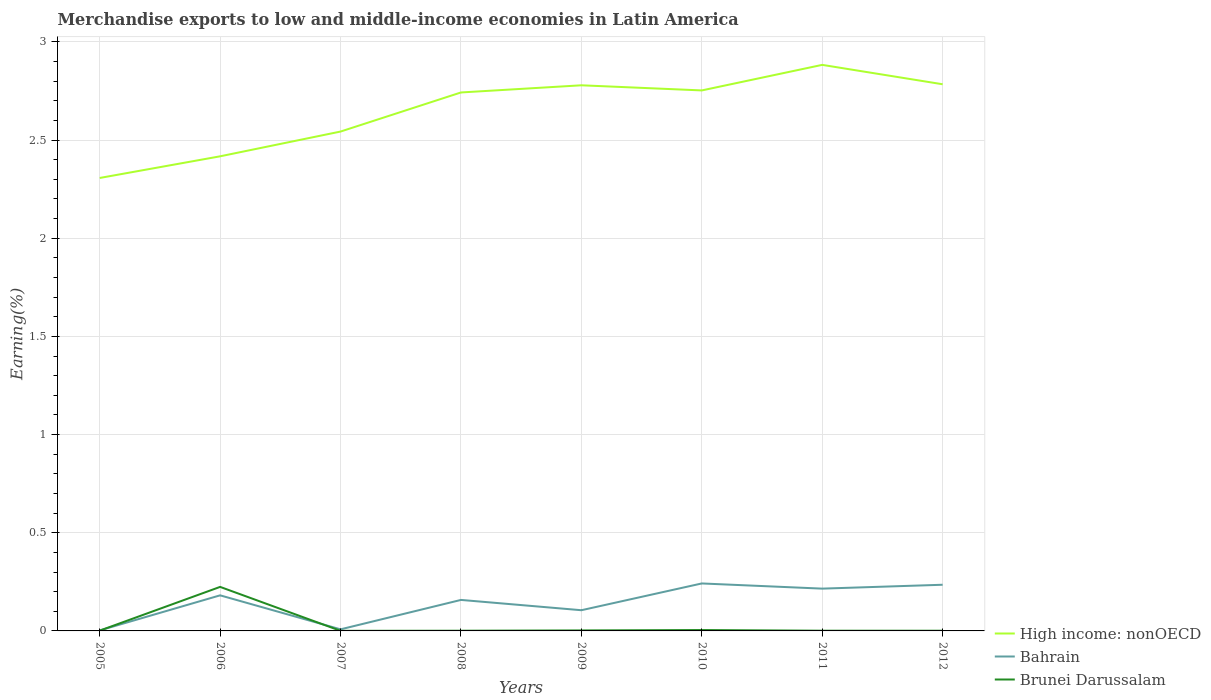Does the line corresponding to High income: nonOECD intersect with the line corresponding to Brunei Darussalam?
Your answer should be compact. No. Is the number of lines equal to the number of legend labels?
Your answer should be compact. Yes. Across all years, what is the maximum percentage of amount earned from merchandise exports in Brunei Darussalam?
Ensure brevity in your answer.  0. What is the total percentage of amount earned from merchandise exports in Brunei Darussalam in the graph?
Your answer should be very brief. 0. What is the difference between the highest and the second highest percentage of amount earned from merchandise exports in Bahrain?
Offer a very short reply. 0.24. What is the difference between the highest and the lowest percentage of amount earned from merchandise exports in Brunei Darussalam?
Your answer should be very brief. 1. How many lines are there?
Offer a terse response. 3. How many years are there in the graph?
Offer a terse response. 8. Are the values on the major ticks of Y-axis written in scientific E-notation?
Offer a terse response. No. Does the graph contain any zero values?
Offer a terse response. No. Where does the legend appear in the graph?
Your response must be concise. Bottom right. How are the legend labels stacked?
Your response must be concise. Vertical. What is the title of the graph?
Provide a short and direct response. Merchandise exports to low and middle-income economies in Latin America. What is the label or title of the X-axis?
Provide a short and direct response. Years. What is the label or title of the Y-axis?
Give a very brief answer. Earning(%). What is the Earning(%) of High income: nonOECD in 2005?
Keep it short and to the point. 2.31. What is the Earning(%) in Bahrain in 2005?
Give a very brief answer. 0. What is the Earning(%) in Brunei Darussalam in 2005?
Your answer should be compact. 0. What is the Earning(%) in High income: nonOECD in 2006?
Offer a very short reply. 2.42. What is the Earning(%) in Bahrain in 2006?
Offer a very short reply. 0.18. What is the Earning(%) of Brunei Darussalam in 2006?
Offer a terse response. 0.22. What is the Earning(%) of High income: nonOECD in 2007?
Provide a short and direct response. 2.54. What is the Earning(%) in Bahrain in 2007?
Give a very brief answer. 0.01. What is the Earning(%) in Brunei Darussalam in 2007?
Your response must be concise. 0. What is the Earning(%) of High income: nonOECD in 2008?
Offer a very short reply. 2.74. What is the Earning(%) of Bahrain in 2008?
Make the answer very short. 0.16. What is the Earning(%) in Brunei Darussalam in 2008?
Your response must be concise. 0. What is the Earning(%) in High income: nonOECD in 2009?
Offer a very short reply. 2.78. What is the Earning(%) in Bahrain in 2009?
Offer a very short reply. 0.11. What is the Earning(%) in Brunei Darussalam in 2009?
Your answer should be compact. 0. What is the Earning(%) of High income: nonOECD in 2010?
Offer a terse response. 2.75. What is the Earning(%) in Bahrain in 2010?
Ensure brevity in your answer.  0.24. What is the Earning(%) in Brunei Darussalam in 2010?
Ensure brevity in your answer.  0. What is the Earning(%) of High income: nonOECD in 2011?
Keep it short and to the point. 2.88. What is the Earning(%) in Bahrain in 2011?
Your response must be concise. 0.22. What is the Earning(%) of Brunei Darussalam in 2011?
Make the answer very short. 0. What is the Earning(%) of High income: nonOECD in 2012?
Your answer should be very brief. 2.78. What is the Earning(%) in Bahrain in 2012?
Offer a terse response. 0.24. What is the Earning(%) of Brunei Darussalam in 2012?
Offer a very short reply. 0. Across all years, what is the maximum Earning(%) of High income: nonOECD?
Make the answer very short. 2.88. Across all years, what is the maximum Earning(%) of Bahrain?
Provide a succinct answer. 0.24. Across all years, what is the maximum Earning(%) in Brunei Darussalam?
Provide a succinct answer. 0.22. Across all years, what is the minimum Earning(%) in High income: nonOECD?
Your response must be concise. 2.31. Across all years, what is the minimum Earning(%) in Bahrain?
Offer a terse response. 0. Across all years, what is the minimum Earning(%) in Brunei Darussalam?
Provide a succinct answer. 0. What is the total Earning(%) in High income: nonOECD in the graph?
Your answer should be compact. 21.21. What is the total Earning(%) of Bahrain in the graph?
Offer a very short reply. 1.15. What is the total Earning(%) of Brunei Darussalam in the graph?
Offer a very short reply. 0.24. What is the difference between the Earning(%) of High income: nonOECD in 2005 and that in 2006?
Provide a short and direct response. -0.11. What is the difference between the Earning(%) in Bahrain in 2005 and that in 2006?
Provide a succinct answer. -0.18. What is the difference between the Earning(%) of Brunei Darussalam in 2005 and that in 2006?
Ensure brevity in your answer.  -0.22. What is the difference between the Earning(%) of High income: nonOECD in 2005 and that in 2007?
Offer a terse response. -0.24. What is the difference between the Earning(%) of Bahrain in 2005 and that in 2007?
Ensure brevity in your answer.  -0.01. What is the difference between the Earning(%) of Brunei Darussalam in 2005 and that in 2007?
Keep it short and to the point. 0. What is the difference between the Earning(%) of High income: nonOECD in 2005 and that in 2008?
Your response must be concise. -0.44. What is the difference between the Earning(%) in Bahrain in 2005 and that in 2008?
Make the answer very short. -0.16. What is the difference between the Earning(%) in Brunei Darussalam in 2005 and that in 2008?
Ensure brevity in your answer.  0. What is the difference between the Earning(%) of High income: nonOECD in 2005 and that in 2009?
Offer a very short reply. -0.47. What is the difference between the Earning(%) of Bahrain in 2005 and that in 2009?
Offer a terse response. -0.1. What is the difference between the Earning(%) in Brunei Darussalam in 2005 and that in 2009?
Give a very brief answer. -0. What is the difference between the Earning(%) in High income: nonOECD in 2005 and that in 2010?
Your answer should be very brief. -0.45. What is the difference between the Earning(%) of Bahrain in 2005 and that in 2010?
Your answer should be compact. -0.24. What is the difference between the Earning(%) of Brunei Darussalam in 2005 and that in 2010?
Provide a short and direct response. -0. What is the difference between the Earning(%) in High income: nonOECD in 2005 and that in 2011?
Your answer should be very brief. -0.58. What is the difference between the Earning(%) of Bahrain in 2005 and that in 2011?
Your answer should be compact. -0.21. What is the difference between the Earning(%) of Brunei Darussalam in 2005 and that in 2011?
Make the answer very short. 0. What is the difference between the Earning(%) in High income: nonOECD in 2005 and that in 2012?
Your response must be concise. -0.48. What is the difference between the Earning(%) of Bahrain in 2005 and that in 2012?
Provide a short and direct response. -0.23. What is the difference between the Earning(%) of Brunei Darussalam in 2005 and that in 2012?
Provide a succinct answer. 0. What is the difference between the Earning(%) in High income: nonOECD in 2006 and that in 2007?
Offer a very short reply. -0.13. What is the difference between the Earning(%) in Bahrain in 2006 and that in 2007?
Your answer should be compact. 0.17. What is the difference between the Earning(%) in Brunei Darussalam in 2006 and that in 2007?
Provide a short and direct response. 0.22. What is the difference between the Earning(%) in High income: nonOECD in 2006 and that in 2008?
Give a very brief answer. -0.33. What is the difference between the Earning(%) in Bahrain in 2006 and that in 2008?
Your answer should be very brief. 0.02. What is the difference between the Earning(%) in Brunei Darussalam in 2006 and that in 2008?
Provide a succinct answer. 0.22. What is the difference between the Earning(%) in High income: nonOECD in 2006 and that in 2009?
Provide a succinct answer. -0.36. What is the difference between the Earning(%) in Bahrain in 2006 and that in 2009?
Offer a terse response. 0.08. What is the difference between the Earning(%) of Brunei Darussalam in 2006 and that in 2009?
Your answer should be compact. 0.22. What is the difference between the Earning(%) in High income: nonOECD in 2006 and that in 2010?
Ensure brevity in your answer.  -0.34. What is the difference between the Earning(%) in Bahrain in 2006 and that in 2010?
Your answer should be very brief. -0.06. What is the difference between the Earning(%) in Brunei Darussalam in 2006 and that in 2010?
Offer a terse response. 0.22. What is the difference between the Earning(%) of High income: nonOECD in 2006 and that in 2011?
Keep it short and to the point. -0.47. What is the difference between the Earning(%) in Bahrain in 2006 and that in 2011?
Ensure brevity in your answer.  -0.03. What is the difference between the Earning(%) in Brunei Darussalam in 2006 and that in 2011?
Provide a succinct answer. 0.22. What is the difference between the Earning(%) in High income: nonOECD in 2006 and that in 2012?
Give a very brief answer. -0.37. What is the difference between the Earning(%) in Bahrain in 2006 and that in 2012?
Offer a very short reply. -0.05. What is the difference between the Earning(%) in Brunei Darussalam in 2006 and that in 2012?
Provide a succinct answer. 0.22. What is the difference between the Earning(%) in High income: nonOECD in 2007 and that in 2008?
Your answer should be very brief. -0.2. What is the difference between the Earning(%) of Bahrain in 2007 and that in 2008?
Offer a terse response. -0.15. What is the difference between the Earning(%) in Brunei Darussalam in 2007 and that in 2008?
Make the answer very short. -0. What is the difference between the Earning(%) in High income: nonOECD in 2007 and that in 2009?
Provide a succinct answer. -0.24. What is the difference between the Earning(%) of Bahrain in 2007 and that in 2009?
Keep it short and to the point. -0.1. What is the difference between the Earning(%) of Brunei Darussalam in 2007 and that in 2009?
Provide a short and direct response. -0. What is the difference between the Earning(%) of High income: nonOECD in 2007 and that in 2010?
Your answer should be very brief. -0.21. What is the difference between the Earning(%) of Bahrain in 2007 and that in 2010?
Your answer should be very brief. -0.23. What is the difference between the Earning(%) of Brunei Darussalam in 2007 and that in 2010?
Provide a succinct answer. -0. What is the difference between the Earning(%) in High income: nonOECD in 2007 and that in 2011?
Your response must be concise. -0.34. What is the difference between the Earning(%) in Bahrain in 2007 and that in 2011?
Your response must be concise. -0.21. What is the difference between the Earning(%) in Brunei Darussalam in 2007 and that in 2011?
Your answer should be very brief. -0. What is the difference between the Earning(%) in High income: nonOECD in 2007 and that in 2012?
Offer a terse response. -0.24. What is the difference between the Earning(%) in Bahrain in 2007 and that in 2012?
Provide a succinct answer. -0.23. What is the difference between the Earning(%) in Brunei Darussalam in 2007 and that in 2012?
Give a very brief answer. -0. What is the difference between the Earning(%) in High income: nonOECD in 2008 and that in 2009?
Ensure brevity in your answer.  -0.04. What is the difference between the Earning(%) of Bahrain in 2008 and that in 2009?
Your answer should be compact. 0.05. What is the difference between the Earning(%) of Brunei Darussalam in 2008 and that in 2009?
Offer a very short reply. -0. What is the difference between the Earning(%) of High income: nonOECD in 2008 and that in 2010?
Ensure brevity in your answer.  -0.01. What is the difference between the Earning(%) in Bahrain in 2008 and that in 2010?
Provide a short and direct response. -0.08. What is the difference between the Earning(%) of Brunei Darussalam in 2008 and that in 2010?
Offer a terse response. -0. What is the difference between the Earning(%) in High income: nonOECD in 2008 and that in 2011?
Ensure brevity in your answer.  -0.14. What is the difference between the Earning(%) of Bahrain in 2008 and that in 2011?
Offer a very short reply. -0.06. What is the difference between the Earning(%) in Brunei Darussalam in 2008 and that in 2011?
Your answer should be very brief. -0. What is the difference between the Earning(%) of High income: nonOECD in 2008 and that in 2012?
Offer a very short reply. -0.04. What is the difference between the Earning(%) of Bahrain in 2008 and that in 2012?
Give a very brief answer. -0.08. What is the difference between the Earning(%) in High income: nonOECD in 2009 and that in 2010?
Make the answer very short. 0.03. What is the difference between the Earning(%) of Bahrain in 2009 and that in 2010?
Make the answer very short. -0.14. What is the difference between the Earning(%) in Brunei Darussalam in 2009 and that in 2010?
Ensure brevity in your answer.  -0. What is the difference between the Earning(%) in High income: nonOECD in 2009 and that in 2011?
Offer a very short reply. -0.1. What is the difference between the Earning(%) in Bahrain in 2009 and that in 2011?
Ensure brevity in your answer.  -0.11. What is the difference between the Earning(%) in Brunei Darussalam in 2009 and that in 2011?
Give a very brief answer. 0. What is the difference between the Earning(%) of High income: nonOECD in 2009 and that in 2012?
Your response must be concise. -0.01. What is the difference between the Earning(%) of Bahrain in 2009 and that in 2012?
Offer a very short reply. -0.13. What is the difference between the Earning(%) of Brunei Darussalam in 2009 and that in 2012?
Your answer should be very brief. 0. What is the difference between the Earning(%) of High income: nonOECD in 2010 and that in 2011?
Your answer should be compact. -0.13. What is the difference between the Earning(%) in Bahrain in 2010 and that in 2011?
Ensure brevity in your answer.  0.03. What is the difference between the Earning(%) in Brunei Darussalam in 2010 and that in 2011?
Your answer should be compact. 0. What is the difference between the Earning(%) of High income: nonOECD in 2010 and that in 2012?
Offer a terse response. -0.03. What is the difference between the Earning(%) of Bahrain in 2010 and that in 2012?
Offer a very short reply. 0.01. What is the difference between the Earning(%) in Brunei Darussalam in 2010 and that in 2012?
Provide a succinct answer. 0. What is the difference between the Earning(%) of High income: nonOECD in 2011 and that in 2012?
Make the answer very short. 0.1. What is the difference between the Earning(%) in Bahrain in 2011 and that in 2012?
Your answer should be very brief. -0.02. What is the difference between the Earning(%) in High income: nonOECD in 2005 and the Earning(%) in Bahrain in 2006?
Offer a very short reply. 2.13. What is the difference between the Earning(%) of High income: nonOECD in 2005 and the Earning(%) of Brunei Darussalam in 2006?
Your response must be concise. 2.08. What is the difference between the Earning(%) of Bahrain in 2005 and the Earning(%) of Brunei Darussalam in 2006?
Ensure brevity in your answer.  -0.22. What is the difference between the Earning(%) in High income: nonOECD in 2005 and the Earning(%) in Bahrain in 2007?
Offer a terse response. 2.3. What is the difference between the Earning(%) of High income: nonOECD in 2005 and the Earning(%) of Brunei Darussalam in 2007?
Your answer should be very brief. 2.31. What is the difference between the Earning(%) of Bahrain in 2005 and the Earning(%) of Brunei Darussalam in 2007?
Provide a succinct answer. 0. What is the difference between the Earning(%) of High income: nonOECD in 2005 and the Earning(%) of Bahrain in 2008?
Offer a very short reply. 2.15. What is the difference between the Earning(%) of High income: nonOECD in 2005 and the Earning(%) of Brunei Darussalam in 2008?
Make the answer very short. 2.31. What is the difference between the Earning(%) of Bahrain in 2005 and the Earning(%) of Brunei Darussalam in 2008?
Your answer should be compact. 0. What is the difference between the Earning(%) of High income: nonOECD in 2005 and the Earning(%) of Bahrain in 2009?
Offer a very short reply. 2.2. What is the difference between the Earning(%) in High income: nonOECD in 2005 and the Earning(%) in Brunei Darussalam in 2009?
Provide a succinct answer. 2.3. What is the difference between the Earning(%) of High income: nonOECD in 2005 and the Earning(%) of Bahrain in 2010?
Your response must be concise. 2.06. What is the difference between the Earning(%) of High income: nonOECD in 2005 and the Earning(%) of Brunei Darussalam in 2010?
Ensure brevity in your answer.  2.3. What is the difference between the Earning(%) of Bahrain in 2005 and the Earning(%) of Brunei Darussalam in 2010?
Offer a terse response. -0. What is the difference between the Earning(%) of High income: nonOECD in 2005 and the Earning(%) of Bahrain in 2011?
Offer a terse response. 2.09. What is the difference between the Earning(%) of High income: nonOECD in 2005 and the Earning(%) of Brunei Darussalam in 2011?
Keep it short and to the point. 2.31. What is the difference between the Earning(%) in Bahrain in 2005 and the Earning(%) in Brunei Darussalam in 2011?
Provide a short and direct response. 0. What is the difference between the Earning(%) of High income: nonOECD in 2005 and the Earning(%) of Bahrain in 2012?
Provide a short and direct response. 2.07. What is the difference between the Earning(%) of High income: nonOECD in 2005 and the Earning(%) of Brunei Darussalam in 2012?
Give a very brief answer. 2.31. What is the difference between the Earning(%) in Bahrain in 2005 and the Earning(%) in Brunei Darussalam in 2012?
Provide a succinct answer. 0. What is the difference between the Earning(%) in High income: nonOECD in 2006 and the Earning(%) in Bahrain in 2007?
Your response must be concise. 2.41. What is the difference between the Earning(%) in High income: nonOECD in 2006 and the Earning(%) in Brunei Darussalam in 2007?
Give a very brief answer. 2.42. What is the difference between the Earning(%) in Bahrain in 2006 and the Earning(%) in Brunei Darussalam in 2007?
Your answer should be compact. 0.18. What is the difference between the Earning(%) of High income: nonOECD in 2006 and the Earning(%) of Bahrain in 2008?
Offer a terse response. 2.26. What is the difference between the Earning(%) in High income: nonOECD in 2006 and the Earning(%) in Brunei Darussalam in 2008?
Keep it short and to the point. 2.42. What is the difference between the Earning(%) of Bahrain in 2006 and the Earning(%) of Brunei Darussalam in 2008?
Make the answer very short. 0.18. What is the difference between the Earning(%) in High income: nonOECD in 2006 and the Earning(%) in Bahrain in 2009?
Ensure brevity in your answer.  2.31. What is the difference between the Earning(%) in High income: nonOECD in 2006 and the Earning(%) in Brunei Darussalam in 2009?
Provide a short and direct response. 2.41. What is the difference between the Earning(%) in Bahrain in 2006 and the Earning(%) in Brunei Darussalam in 2009?
Ensure brevity in your answer.  0.18. What is the difference between the Earning(%) in High income: nonOECD in 2006 and the Earning(%) in Bahrain in 2010?
Make the answer very short. 2.18. What is the difference between the Earning(%) in High income: nonOECD in 2006 and the Earning(%) in Brunei Darussalam in 2010?
Ensure brevity in your answer.  2.41. What is the difference between the Earning(%) of Bahrain in 2006 and the Earning(%) of Brunei Darussalam in 2010?
Offer a terse response. 0.18. What is the difference between the Earning(%) in High income: nonOECD in 2006 and the Earning(%) in Bahrain in 2011?
Provide a succinct answer. 2.2. What is the difference between the Earning(%) of High income: nonOECD in 2006 and the Earning(%) of Brunei Darussalam in 2011?
Ensure brevity in your answer.  2.42. What is the difference between the Earning(%) of Bahrain in 2006 and the Earning(%) of Brunei Darussalam in 2011?
Offer a very short reply. 0.18. What is the difference between the Earning(%) of High income: nonOECD in 2006 and the Earning(%) of Bahrain in 2012?
Your answer should be compact. 2.18. What is the difference between the Earning(%) in High income: nonOECD in 2006 and the Earning(%) in Brunei Darussalam in 2012?
Ensure brevity in your answer.  2.42. What is the difference between the Earning(%) of Bahrain in 2006 and the Earning(%) of Brunei Darussalam in 2012?
Offer a terse response. 0.18. What is the difference between the Earning(%) of High income: nonOECD in 2007 and the Earning(%) of Bahrain in 2008?
Offer a very short reply. 2.39. What is the difference between the Earning(%) in High income: nonOECD in 2007 and the Earning(%) in Brunei Darussalam in 2008?
Make the answer very short. 2.54. What is the difference between the Earning(%) in Bahrain in 2007 and the Earning(%) in Brunei Darussalam in 2008?
Ensure brevity in your answer.  0.01. What is the difference between the Earning(%) in High income: nonOECD in 2007 and the Earning(%) in Bahrain in 2009?
Offer a very short reply. 2.44. What is the difference between the Earning(%) of High income: nonOECD in 2007 and the Earning(%) of Brunei Darussalam in 2009?
Offer a terse response. 2.54. What is the difference between the Earning(%) of Bahrain in 2007 and the Earning(%) of Brunei Darussalam in 2009?
Give a very brief answer. 0.01. What is the difference between the Earning(%) of High income: nonOECD in 2007 and the Earning(%) of Bahrain in 2010?
Make the answer very short. 2.3. What is the difference between the Earning(%) in High income: nonOECD in 2007 and the Earning(%) in Brunei Darussalam in 2010?
Provide a succinct answer. 2.54. What is the difference between the Earning(%) of Bahrain in 2007 and the Earning(%) of Brunei Darussalam in 2010?
Make the answer very short. 0. What is the difference between the Earning(%) in High income: nonOECD in 2007 and the Earning(%) in Bahrain in 2011?
Provide a succinct answer. 2.33. What is the difference between the Earning(%) of High income: nonOECD in 2007 and the Earning(%) of Brunei Darussalam in 2011?
Offer a very short reply. 2.54. What is the difference between the Earning(%) of Bahrain in 2007 and the Earning(%) of Brunei Darussalam in 2011?
Provide a short and direct response. 0.01. What is the difference between the Earning(%) of High income: nonOECD in 2007 and the Earning(%) of Bahrain in 2012?
Give a very brief answer. 2.31. What is the difference between the Earning(%) in High income: nonOECD in 2007 and the Earning(%) in Brunei Darussalam in 2012?
Your answer should be compact. 2.54. What is the difference between the Earning(%) of Bahrain in 2007 and the Earning(%) of Brunei Darussalam in 2012?
Offer a very short reply. 0.01. What is the difference between the Earning(%) in High income: nonOECD in 2008 and the Earning(%) in Bahrain in 2009?
Your response must be concise. 2.64. What is the difference between the Earning(%) in High income: nonOECD in 2008 and the Earning(%) in Brunei Darussalam in 2009?
Offer a very short reply. 2.74. What is the difference between the Earning(%) in Bahrain in 2008 and the Earning(%) in Brunei Darussalam in 2009?
Your answer should be compact. 0.16. What is the difference between the Earning(%) in High income: nonOECD in 2008 and the Earning(%) in Bahrain in 2010?
Provide a succinct answer. 2.5. What is the difference between the Earning(%) in High income: nonOECD in 2008 and the Earning(%) in Brunei Darussalam in 2010?
Your answer should be very brief. 2.74. What is the difference between the Earning(%) of Bahrain in 2008 and the Earning(%) of Brunei Darussalam in 2010?
Offer a terse response. 0.15. What is the difference between the Earning(%) in High income: nonOECD in 2008 and the Earning(%) in Bahrain in 2011?
Make the answer very short. 2.53. What is the difference between the Earning(%) of High income: nonOECD in 2008 and the Earning(%) of Brunei Darussalam in 2011?
Make the answer very short. 2.74. What is the difference between the Earning(%) in Bahrain in 2008 and the Earning(%) in Brunei Darussalam in 2011?
Provide a succinct answer. 0.16. What is the difference between the Earning(%) in High income: nonOECD in 2008 and the Earning(%) in Bahrain in 2012?
Your answer should be compact. 2.51. What is the difference between the Earning(%) of High income: nonOECD in 2008 and the Earning(%) of Brunei Darussalam in 2012?
Offer a terse response. 2.74. What is the difference between the Earning(%) of Bahrain in 2008 and the Earning(%) of Brunei Darussalam in 2012?
Your response must be concise. 0.16. What is the difference between the Earning(%) in High income: nonOECD in 2009 and the Earning(%) in Bahrain in 2010?
Ensure brevity in your answer.  2.54. What is the difference between the Earning(%) of High income: nonOECD in 2009 and the Earning(%) of Brunei Darussalam in 2010?
Your response must be concise. 2.77. What is the difference between the Earning(%) of Bahrain in 2009 and the Earning(%) of Brunei Darussalam in 2010?
Your answer should be very brief. 0.1. What is the difference between the Earning(%) in High income: nonOECD in 2009 and the Earning(%) in Bahrain in 2011?
Provide a short and direct response. 2.56. What is the difference between the Earning(%) of High income: nonOECD in 2009 and the Earning(%) of Brunei Darussalam in 2011?
Ensure brevity in your answer.  2.78. What is the difference between the Earning(%) of Bahrain in 2009 and the Earning(%) of Brunei Darussalam in 2011?
Provide a short and direct response. 0.1. What is the difference between the Earning(%) of High income: nonOECD in 2009 and the Earning(%) of Bahrain in 2012?
Your answer should be very brief. 2.54. What is the difference between the Earning(%) in High income: nonOECD in 2009 and the Earning(%) in Brunei Darussalam in 2012?
Keep it short and to the point. 2.78. What is the difference between the Earning(%) in Bahrain in 2009 and the Earning(%) in Brunei Darussalam in 2012?
Offer a terse response. 0.1. What is the difference between the Earning(%) in High income: nonOECD in 2010 and the Earning(%) in Bahrain in 2011?
Your response must be concise. 2.54. What is the difference between the Earning(%) of High income: nonOECD in 2010 and the Earning(%) of Brunei Darussalam in 2011?
Make the answer very short. 2.75. What is the difference between the Earning(%) in Bahrain in 2010 and the Earning(%) in Brunei Darussalam in 2011?
Your answer should be very brief. 0.24. What is the difference between the Earning(%) of High income: nonOECD in 2010 and the Earning(%) of Bahrain in 2012?
Provide a short and direct response. 2.52. What is the difference between the Earning(%) of High income: nonOECD in 2010 and the Earning(%) of Brunei Darussalam in 2012?
Provide a short and direct response. 2.75. What is the difference between the Earning(%) of Bahrain in 2010 and the Earning(%) of Brunei Darussalam in 2012?
Your answer should be very brief. 0.24. What is the difference between the Earning(%) in High income: nonOECD in 2011 and the Earning(%) in Bahrain in 2012?
Keep it short and to the point. 2.65. What is the difference between the Earning(%) in High income: nonOECD in 2011 and the Earning(%) in Brunei Darussalam in 2012?
Provide a short and direct response. 2.88. What is the difference between the Earning(%) of Bahrain in 2011 and the Earning(%) of Brunei Darussalam in 2012?
Your response must be concise. 0.21. What is the average Earning(%) in High income: nonOECD per year?
Offer a terse response. 2.65. What is the average Earning(%) of Bahrain per year?
Offer a very short reply. 0.14. What is the average Earning(%) of Brunei Darussalam per year?
Offer a very short reply. 0.03. In the year 2005, what is the difference between the Earning(%) of High income: nonOECD and Earning(%) of Bahrain?
Offer a terse response. 2.3. In the year 2005, what is the difference between the Earning(%) of High income: nonOECD and Earning(%) of Brunei Darussalam?
Offer a very short reply. 2.31. In the year 2005, what is the difference between the Earning(%) in Bahrain and Earning(%) in Brunei Darussalam?
Give a very brief answer. 0. In the year 2006, what is the difference between the Earning(%) of High income: nonOECD and Earning(%) of Bahrain?
Your response must be concise. 2.24. In the year 2006, what is the difference between the Earning(%) in High income: nonOECD and Earning(%) in Brunei Darussalam?
Your answer should be very brief. 2.19. In the year 2006, what is the difference between the Earning(%) in Bahrain and Earning(%) in Brunei Darussalam?
Offer a terse response. -0.04. In the year 2007, what is the difference between the Earning(%) of High income: nonOECD and Earning(%) of Bahrain?
Ensure brevity in your answer.  2.54. In the year 2007, what is the difference between the Earning(%) in High income: nonOECD and Earning(%) in Brunei Darussalam?
Offer a very short reply. 2.54. In the year 2007, what is the difference between the Earning(%) in Bahrain and Earning(%) in Brunei Darussalam?
Make the answer very short. 0.01. In the year 2008, what is the difference between the Earning(%) of High income: nonOECD and Earning(%) of Bahrain?
Ensure brevity in your answer.  2.58. In the year 2008, what is the difference between the Earning(%) of High income: nonOECD and Earning(%) of Brunei Darussalam?
Your answer should be compact. 2.74. In the year 2008, what is the difference between the Earning(%) of Bahrain and Earning(%) of Brunei Darussalam?
Your answer should be compact. 0.16. In the year 2009, what is the difference between the Earning(%) in High income: nonOECD and Earning(%) in Bahrain?
Offer a very short reply. 2.67. In the year 2009, what is the difference between the Earning(%) in High income: nonOECD and Earning(%) in Brunei Darussalam?
Keep it short and to the point. 2.78. In the year 2009, what is the difference between the Earning(%) of Bahrain and Earning(%) of Brunei Darussalam?
Make the answer very short. 0.1. In the year 2010, what is the difference between the Earning(%) of High income: nonOECD and Earning(%) of Bahrain?
Provide a short and direct response. 2.51. In the year 2010, what is the difference between the Earning(%) of High income: nonOECD and Earning(%) of Brunei Darussalam?
Provide a succinct answer. 2.75. In the year 2010, what is the difference between the Earning(%) of Bahrain and Earning(%) of Brunei Darussalam?
Offer a terse response. 0.24. In the year 2011, what is the difference between the Earning(%) of High income: nonOECD and Earning(%) of Bahrain?
Your answer should be very brief. 2.67. In the year 2011, what is the difference between the Earning(%) in High income: nonOECD and Earning(%) in Brunei Darussalam?
Keep it short and to the point. 2.88. In the year 2011, what is the difference between the Earning(%) in Bahrain and Earning(%) in Brunei Darussalam?
Your response must be concise. 0.21. In the year 2012, what is the difference between the Earning(%) of High income: nonOECD and Earning(%) of Bahrain?
Your answer should be compact. 2.55. In the year 2012, what is the difference between the Earning(%) in High income: nonOECD and Earning(%) in Brunei Darussalam?
Provide a short and direct response. 2.78. In the year 2012, what is the difference between the Earning(%) in Bahrain and Earning(%) in Brunei Darussalam?
Provide a succinct answer. 0.23. What is the ratio of the Earning(%) of High income: nonOECD in 2005 to that in 2006?
Keep it short and to the point. 0.95. What is the ratio of the Earning(%) of Bahrain in 2005 to that in 2006?
Offer a very short reply. 0.01. What is the ratio of the Earning(%) in Brunei Darussalam in 2005 to that in 2006?
Your answer should be compact. 0.01. What is the ratio of the Earning(%) of High income: nonOECD in 2005 to that in 2007?
Provide a short and direct response. 0.91. What is the ratio of the Earning(%) of Bahrain in 2005 to that in 2007?
Your response must be concise. 0.32. What is the ratio of the Earning(%) in Brunei Darussalam in 2005 to that in 2007?
Make the answer very short. 2.95. What is the ratio of the Earning(%) of High income: nonOECD in 2005 to that in 2008?
Ensure brevity in your answer.  0.84. What is the ratio of the Earning(%) of Bahrain in 2005 to that in 2008?
Make the answer very short. 0.02. What is the ratio of the Earning(%) of Brunei Darussalam in 2005 to that in 2008?
Offer a very short reply. 1.37. What is the ratio of the Earning(%) in High income: nonOECD in 2005 to that in 2009?
Ensure brevity in your answer.  0.83. What is the ratio of the Earning(%) in Bahrain in 2005 to that in 2009?
Make the answer very short. 0.02. What is the ratio of the Earning(%) in Brunei Darussalam in 2005 to that in 2009?
Provide a short and direct response. 0.54. What is the ratio of the Earning(%) of High income: nonOECD in 2005 to that in 2010?
Keep it short and to the point. 0.84. What is the ratio of the Earning(%) of Bahrain in 2005 to that in 2010?
Ensure brevity in your answer.  0.01. What is the ratio of the Earning(%) in Brunei Darussalam in 2005 to that in 2010?
Your answer should be very brief. 0.31. What is the ratio of the Earning(%) in High income: nonOECD in 2005 to that in 2011?
Keep it short and to the point. 0.8. What is the ratio of the Earning(%) of Bahrain in 2005 to that in 2011?
Your answer should be compact. 0.01. What is the ratio of the Earning(%) in Brunei Darussalam in 2005 to that in 2011?
Make the answer very short. 1.29. What is the ratio of the Earning(%) of High income: nonOECD in 2005 to that in 2012?
Give a very brief answer. 0.83. What is the ratio of the Earning(%) in Bahrain in 2005 to that in 2012?
Your answer should be very brief. 0.01. What is the ratio of the Earning(%) of Brunei Darussalam in 2005 to that in 2012?
Provide a short and direct response. 1.32. What is the ratio of the Earning(%) of High income: nonOECD in 2006 to that in 2007?
Offer a very short reply. 0.95. What is the ratio of the Earning(%) of Bahrain in 2006 to that in 2007?
Your response must be concise. 22.42. What is the ratio of the Earning(%) in Brunei Darussalam in 2006 to that in 2007?
Ensure brevity in your answer.  476.59. What is the ratio of the Earning(%) in High income: nonOECD in 2006 to that in 2008?
Provide a succinct answer. 0.88. What is the ratio of the Earning(%) in Bahrain in 2006 to that in 2008?
Keep it short and to the point. 1.15. What is the ratio of the Earning(%) of Brunei Darussalam in 2006 to that in 2008?
Keep it short and to the point. 220.83. What is the ratio of the Earning(%) of High income: nonOECD in 2006 to that in 2009?
Your answer should be compact. 0.87. What is the ratio of the Earning(%) of Bahrain in 2006 to that in 2009?
Provide a short and direct response. 1.72. What is the ratio of the Earning(%) of Brunei Darussalam in 2006 to that in 2009?
Provide a succinct answer. 87.28. What is the ratio of the Earning(%) of High income: nonOECD in 2006 to that in 2010?
Provide a succinct answer. 0.88. What is the ratio of the Earning(%) in Bahrain in 2006 to that in 2010?
Offer a very short reply. 0.75. What is the ratio of the Earning(%) in Brunei Darussalam in 2006 to that in 2010?
Offer a very short reply. 49.51. What is the ratio of the Earning(%) in High income: nonOECD in 2006 to that in 2011?
Make the answer very short. 0.84. What is the ratio of the Earning(%) of Bahrain in 2006 to that in 2011?
Keep it short and to the point. 0.84. What is the ratio of the Earning(%) in Brunei Darussalam in 2006 to that in 2011?
Give a very brief answer. 208.4. What is the ratio of the Earning(%) of High income: nonOECD in 2006 to that in 2012?
Your answer should be compact. 0.87. What is the ratio of the Earning(%) of Bahrain in 2006 to that in 2012?
Your answer should be very brief. 0.77. What is the ratio of the Earning(%) of Brunei Darussalam in 2006 to that in 2012?
Make the answer very short. 212.37. What is the ratio of the Earning(%) in High income: nonOECD in 2007 to that in 2008?
Ensure brevity in your answer.  0.93. What is the ratio of the Earning(%) of Bahrain in 2007 to that in 2008?
Your answer should be compact. 0.05. What is the ratio of the Earning(%) of Brunei Darussalam in 2007 to that in 2008?
Give a very brief answer. 0.46. What is the ratio of the Earning(%) in High income: nonOECD in 2007 to that in 2009?
Your response must be concise. 0.92. What is the ratio of the Earning(%) in Bahrain in 2007 to that in 2009?
Give a very brief answer. 0.08. What is the ratio of the Earning(%) in Brunei Darussalam in 2007 to that in 2009?
Your answer should be compact. 0.18. What is the ratio of the Earning(%) in High income: nonOECD in 2007 to that in 2010?
Your answer should be compact. 0.92. What is the ratio of the Earning(%) of Bahrain in 2007 to that in 2010?
Provide a short and direct response. 0.03. What is the ratio of the Earning(%) of Brunei Darussalam in 2007 to that in 2010?
Ensure brevity in your answer.  0.1. What is the ratio of the Earning(%) in High income: nonOECD in 2007 to that in 2011?
Offer a terse response. 0.88. What is the ratio of the Earning(%) in Bahrain in 2007 to that in 2011?
Provide a short and direct response. 0.04. What is the ratio of the Earning(%) in Brunei Darussalam in 2007 to that in 2011?
Your answer should be very brief. 0.44. What is the ratio of the Earning(%) of High income: nonOECD in 2007 to that in 2012?
Give a very brief answer. 0.91. What is the ratio of the Earning(%) of Bahrain in 2007 to that in 2012?
Offer a very short reply. 0.03. What is the ratio of the Earning(%) in Brunei Darussalam in 2007 to that in 2012?
Offer a terse response. 0.45. What is the ratio of the Earning(%) of High income: nonOECD in 2008 to that in 2009?
Make the answer very short. 0.99. What is the ratio of the Earning(%) in Bahrain in 2008 to that in 2009?
Offer a very short reply. 1.5. What is the ratio of the Earning(%) of Brunei Darussalam in 2008 to that in 2009?
Offer a very short reply. 0.4. What is the ratio of the Earning(%) of Bahrain in 2008 to that in 2010?
Your answer should be compact. 0.65. What is the ratio of the Earning(%) of Brunei Darussalam in 2008 to that in 2010?
Provide a succinct answer. 0.22. What is the ratio of the Earning(%) of High income: nonOECD in 2008 to that in 2011?
Give a very brief answer. 0.95. What is the ratio of the Earning(%) in Bahrain in 2008 to that in 2011?
Your answer should be compact. 0.73. What is the ratio of the Earning(%) of Brunei Darussalam in 2008 to that in 2011?
Offer a terse response. 0.94. What is the ratio of the Earning(%) of Bahrain in 2008 to that in 2012?
Provide a succinct answer. 0.67. What is the ratio of the Earning(%) in Brunei Darussalam in 2008 to that in 2012?
Offer a terse response. 0.96. What is the ratio of the Earning(%) in High income: nonOECD in 2009 to that in 2010?
Give a very brief answer. 1.01. What is the ratio of the Earning(%) in Bahrain in 2009 to that in 2010?
Your response must be concise. 0.44. What is the ratio of the Earning(%) of Brunei Darussalam in 2009 to that in 2010?
Ensure brevity in your answer.  0.57. What is the ratio of the Earning(%) in High income: nonOECD in 2009 to that in 2011?
Keep it short and to the point. 0.96. What is the ratio of the Earning(%) in Bahrain in 2009 to that in 2011?
Your response must be concise. 0.49. What is the ratio of the Earning(%) of Brunei Darussalam in 2009 to that in 2011?
Offer a terse response. 2.39. What is the ratio of the Earning(%) of High income: nonOECD in 2009 to that in 2012?
Give a very brief answer. 1. What is the ratio of the Earning(%) of Bahrain in 2009 to that in 2012?
Your answer should be very brief. 0.45. What is the ratio of the Earning(%) in Brunei Darussalam in 2009 to that in 2012?
Provide a succinct answer. 2.43. What is the ratio of the Earning(%) in High income: nonOECD in 2010 to that in 2011?
Keep it short and to the point. 0.95. What is the ratio of the Earning(%) in Bahrain in 2010 to that in 2011?
Offer a terse response. 1.12. What is the ratio of the Earning(%) of Brunei Darussalam in 2010 to that in 2011?
Make the answer very short. 4.21. What is the ratio of the Earning(%) in High income: nonOECD in 2010 to that in 2012?
Your answer should be very brief. 0.99. What is the ratio of the Earning(%) in Bahrain in 2010 to that in 2012?
Ensure brevity in your answer.  1.03. What is the ratio of the Earning(%) of Brunei Darussalam in 2010 to that in 2012?
Keep it short and to the point. 4.29. What is the ratio of the Earning(%) in High income: nonOECD in 2011 to that in 2012?
Your response must be concise. 1.04. What is the ratio of the Earning(%) in Bahrain in 2011 to that in 2012?
Offer a very short reply. 0.92. What is the ratio of the Earning(%) of Brunei Darussalam in 2011 to that in 2012?
Your answer should be very brief. 1.02. What is the difference between the highest and the second highest Earning(%) of High income: nonOECD?
Your answer should be compact. 0.1. What is the difference between the highest and the second highest Earning(%) of Bahrain?
Your response must be concise. 0.01. What is the difference between the highest and the second highest Earning(%) of Brunei Darussalam?
Offer a very short reply. 0.22. What is the difference between the highest and the lowest Earning(%) of High income: nonOECD?
Ensure brevity in your answer.  0.58. What is the difference between the highest and the lowest Earning(%) of Bahrain?
Make the answer very short. 0.24. What is the difference between the highest and the lowest Earning(%) in Brunei Darussalam?
Your answer should be very brief. 0.22. 